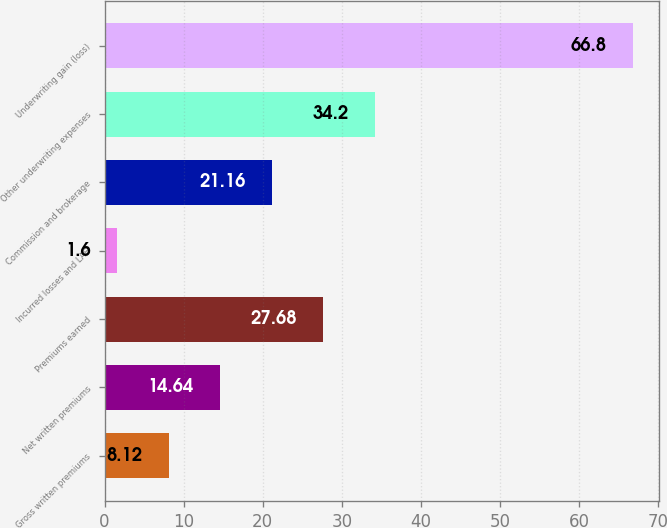Convert chart to OTSL. <chart><loc_0><loc_0><loc_500><loc_500><bar_chart><fcel>Gross written premiums<fcel>Net written premiums<fcel>Premiums earned<fcel>Incurred losses and LAE<fcel>Commission and brokerage<fcel>Other underwriting expenses<fcel>Underwriting gain (loss)<nl><fcel>8.12<fcel>14.64<fcel>27.68<fcel>1.6<fcel>21.16<fcel>34.2<fcel>66.8<nl></chart> 